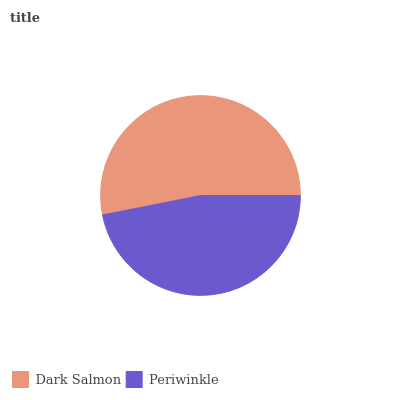Is Periwinkle the minimum?
Answer yes or no. Yes. Is Dark Salmon the maximum?
Answer yes or no. Yes. Is Periwinkle the maximum?
Answer yes or no. No. Is Dark Salmon greater than Periwinkle?
Answer yes or no. Yes. Is Periwinkle less than Dark Salmon?
Answer yes or no. Yes. Is Periwinkle greater than Dark Salmon?
Answer yes or no. No. Is Dark Salmon less than Periwinkle?
Answer yes or no. No. Is Dark Salmon the high median?
Answer yes or no. Yes. Is Periwinkle the low median?
Answer yes or no. Yes. Is Periwinkle the high median?
Answer yes or no. No. Is Dark Salmon the low median?
Answer yes or no. No. 